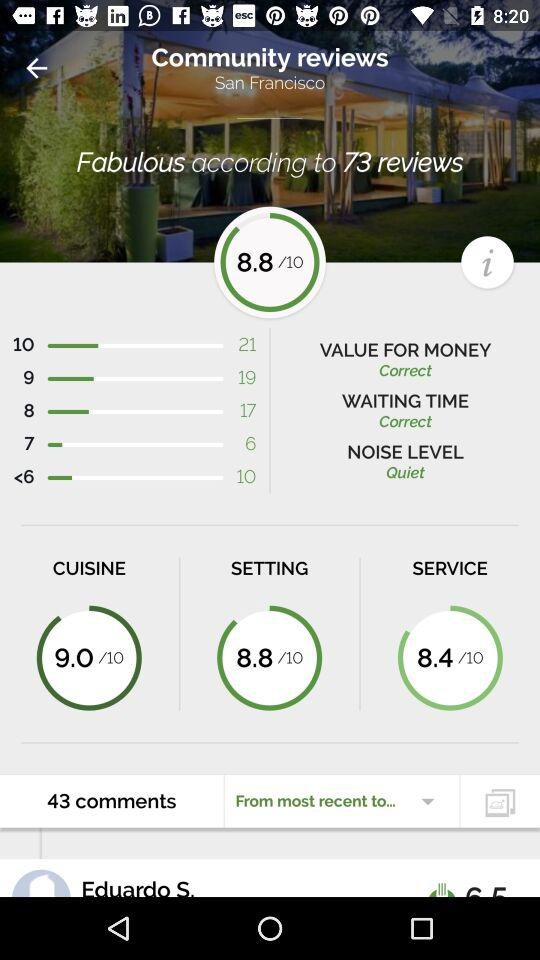What is the rating given by the viewers out of 10 for "SERVICE"? The rating given by the viewers out of 10 for "SERVICE" is 8.4. 